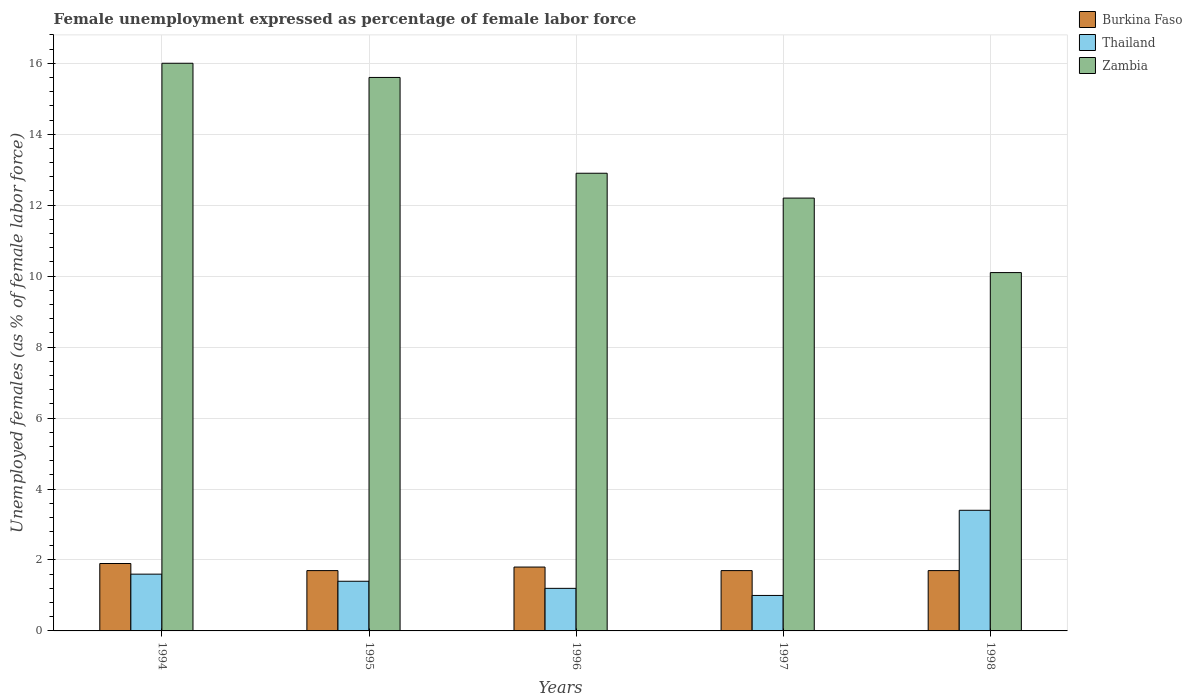How many different coloured bars are there?
Your response must be concise. 3. How many groups of bars are there?
Offer a terse response. 5. Are the number of bars per tick equal to the number of legend labels?
Provide a short and direct response. Yes. Are the number of bars on each tick of the X-axis equal?
Give a very brief answer. Yes. What is the unemployment in females in in Burkina Faso in 1998?
Ensure brevity in your answer.  1.7. What is the total unemployment in females in in Burkina Faso in the graph?
Give a very brief answer. 8.8. What is the difference between the unemployment in females in in Burkina Faso in 1996 and that in 1998?
Your answer should be very brief. 0.1. What is the difference between the unemployment in females in in Thailand in 1997 and the unemployment in females in in Zambia in 1998?
Give a very brief answer. -9.1. What is the average unemployment in females in in Zambia per year?
Make the answer very short. 13.36. In the year 1995, what is the difference between the unemployment in females in in Zambia and unemployment in females in in Thailand?
Offer a very short reply. 14.2. What is the difference between the highest and the second highest unemployment in females in in Burkina Faso?
Your response must be concise. 0.1. What is the difference between the highest and the lowest unemployment in females in in Thailand?
Your answer should be compact. 2.4. In how many years, is the unemployment in females in in Thailand greater than the average unemployment in females in in Thailand taken over all years?
Your response must be concise. 1. What does the 3rd bar from the left in 1994 represents?
Ensure brevity in your answer.  Zambia. What does the 3rd bar from the right in 1995 represents?
Your answer should be compact. Burkina Faso. Is it the case that in every year, the sum of the unemployment in females in in Zambia and unemployment in females in in Burkina Faso is greater than the unemployment in females in in Thailand?
Ensure brevity in your answer.  Yes. How many bars are there?
Give a very brief answer. 15. Are all the bars in the graph horizontal?
Your response must be concise. No. Are the values on the major ticks of Y-axis written in scientific E-notation?
Your answer should be compact. No. Where does the legend appear in the graph?
Offer a terse response. Top right. How many legend labels are there?
Ensure brevity in your answer.  3. How are the legend labels stacked?
Your response must be concise. Vertical. What is the title of the graph?
Your answer should be compact. Female unemployment expressed as percentage of female labor force. Does "Haiti" appear as one of the legend labels in the graph?
Provide a succinct answer. No. What is the label or title of the X-axis?
Your response must be concise. Years. What is the label or title of the Y-axis?
Offer a terse response. Unemployed females (as % of female labor force). What is the Unemployed females (as % of female labor force) of Burkina Faso in 1994?
Provide a short and direct response. 1.9. What is the Unemployed females (as % of female labor force) of Thailand in 1994?
Give a very brief answer. 1.6. What is the Unemployed females (as % of female labor force) of Zambia in 1994?
Your answer should be compact. 16. What is the Unemployed females (as % of female labor force) of Burkina Faso in 1995?
Offer a very short reply. 1.7. What is the Unemployed females (as % of female labor force) of Thailand in 1995?
Offer a very short reply. 1.4. What is the Unemployed females (as % of female labor force) in Zambia in 1995?
Provide a short and direct response. 15.6. What is the Unemployed females (as % of female labor force) in Burkina Faso in 1996?
Your response must be concise. 1.8. What is the Unemployed females (as % of female labor force) in Thailand in 1996?
Offer a very short reply. 1.2. What is the Unemployed females (as % of female labor force) in Zambia in 1996?
Your answer should be very brief. 12.9. What is the Unemployed females (as % of female labor force) in Burkina Faso in 1997?
Your response must be concise. 1.7. What is the Unemployed females (as % of female labor force) of Thailand in 1997?
Offer a very short reply. 1. What is the Unemployed females (as % of female labor force) of Zambia in 1997?
Offer a very short reply. 12.2. What is the Unemployed females (as % of female labor force) in Burkina Faso in 1998?
Make the answer very short. 1.7. What is the Unemployed females (as % of female labor force) of Thailand in 1998?
Ensure brevity in your answer.  3.4. What is the Unemployed females (as % of female labor force) in Zambia in 1998?
Make the answer very short. 10.1. Across all years, what is the maximum Unemployed females (as % of female labor force) in Burkina Faso?
Your answer should be compact. 1.9. Across all years, what is the maximum Unemployed females (as % of female labor force) in Thailand?
Give a very brief answer. 3.4. Across all years, what is the minimum Unemployed females (as % of female labor force) of Burkina Faso?
Offer a very short reply. 1.7. Across all years, what is the minimum Unemployed females (as % of female labor force) of Thailand?
Keep it short and to the point. 1. Across all years, what is the minimum Unemployed females (as % of female labor force) in Zambia?
Provide a succinct answer. 10.1. What is the total Unemployed females (as % of female labor force) in Burkina Faso in the graph?
Keep it short and to the point. 8.8. What is the total Unemployed females (as % of female labor force) in Thailand in the graph?
Keep it short and to the point. 8.6. What is the total Unemployed females (as % of female labor force) of Zambia in the graph?
Your response must be concise. 66.8. What is the difference between the Unemployed females (as % of female labor force) in Thailand in 1994 and that in 1996?
Provide a short and direct response. 0.4. What is the difference between the Unemployed females (as % of female labor force) in Zambia in 1994 and that in 1998?
Provide a short and direct response. 5.9. What is the difference between the Unemployed females (as % of female labor force) of Burkina Faso in 1995 and that in 1996?
Keep it short and to the point. -0.1. What is the difference between the Unemployed females (as % of female labor force) in Thailand in 1995 and that in 1996?
Give a very brief answer. 0.2. What is the difference between the Unemployed females (as % of female labor force) in Zambia in 1995 and that in 1996?
Provide a short and direct response. 2.7. What is the difference between the Unemployed females (as % of female labor force) in Burkina Faso in 1995 and that in 1997?
Provide a succinct answer. 0. What is the difference between the Unemployed females (as % of female labor force) in Thailand in 1996 and that in 1997?
Keep it short and to the point. 0.2. What is the difference between the Unemployed females (as % of female labor force) of Zambia in 1996 and that in 1997?
Your answer should be very brief. 0.7. What is the difference between the Unemployed females (as % of female labor force) in Burkina Faso in 1996 and that in 1998?
Offer a terse response. 0.1. What is the difference between the Unemployed females (as % of female labor force) of Thailand in 1996 and that in 1998?
Give a very brief answer. -2.2. What is the difference between the Unemployed females (as % of female labor force) in Zambia in 1996 and that in 1998?
Your response must be concise. 2.8. What is the difference between the Unemployed females (as % of female labor force) of Thailand in 1997 and that in 1998?
Ensure brevity in your answer.  -2.4. What is the difference between the Unemployed females (as % of female labor force) of Zambia in 1997 and that in 1998?
Provide a succinct answer. 2.1. What is the difference between the Unemployed females (as % of female labor force) in Burkina Faso in 1994 and the Unemployed females (as % of female labor force) in Zambia in 1995?
Offer a terse response. -13.7. What is the difference between the Unemployed females (as % of female labor force) of Burkina Faso in 1994 and the Unemployed females (as % of female labor force) of Thailand in 1996?
Ensure brevity in your answer.  0.7. What is the difference between the Unemployed females (as % of female labor force) in Thailand in 1994 and the Unemployed females (as % of female labor force) in Zambia in 1996?
Make the answer very short. -11.3. What is the difference between the Unemployed females (as % of female labor force) in Burkina Faso in 1994 and the Unemployed females (as % of female labor force) in Zambia in 1997?
Your answer should be very brief. -10.3. What is the difference between the Unemployed females (as % of female labor force) of Burkina Faso in 1994 and the Unemployed females (as % of female labor force) of Zambia in 1998?
Provide a short and direct response. -8.2. What is the difference between the Unemployed females (as % of female labor force) in Thailand in 1995 and the Unemployed females (as % of female labor force) in Zambia in 1997?
Provide a succinct answer. -10.8. What is the difference between the Unemployed females (as % of female labor force) of Burkina Faso in 1995 and the Unemployed females (as % of female labor force) of Zambia in 1998?
Make the answer very short. -8.4. What is the difference between the Unemployed females (as % of female labor force) in Burkina Faso in 1996 and the Unemployed females (as % of female labor force) in Thailand in 1997?
Your answer should be compact. 0.8. What is the difference between the Unemployed females (as % of female labor force) in Burkina Faso in 1996 and the Unemployed females (as % of female labor force) in Zambia in 1997?
Give a very brief answer. -10.4. What is the difference between the Unemployed females (as % of female labor force) of Thailand in 1996 and the Unemployed females (as % of female labor force) of Zambia in 1997?
Your answer should be very brief. -11. What is the difference between the Unemployed females (as % of female labor force) in Burkina Faso in 1996 and the Unemployed females (as % of female labor force) in Zambia in 1998?
Your response must be concise. -8.3. What is the difference between the Unemployed females (as % of female labor force) in Thailand in 1996 and the Unemployed females (as % of female labor force) in Zambia in 1998?
Provide a short and direct response. -8.9. What is the difference between the Unemployed females (as % of female labor force) of Thailand in 1997 and the Unemployed females (as % of female labor force) of Zambia in 1998?
Offer a very short reply. -9.1. What is the average Unemployed females (as % of female labor force) of Burkina Faso per year?
Your response must be concise. 1.76. What is the average Unemployed females (as % of female labor force) of Thailand per year?
Your response must be concise. 1.72. What is the average Unemployed females (as % of female labor force) in Zambia per year?
Your response must be concise. 13.36. In the year 1994, what is the difference between the Unemployed females (as % of female labor force) of Burkina Faso and Unemployed females (as % of female labor force) of Zambia?
Ensure brevity in your answer.  -14.1. In the year 1994, what is the difference between the Unemployed females (as % of female labor force) in Thailand and Unemployed females (as % of female labor force) in Zambia?
Your response must be concise. -14.4. In the year 1995, what is the difference between the Unemployed females (as % of female labor force) in Burkina Faso and Unemployed females (as % of female labor force) in Thailand?
Give a very brief answer. 0.3. In the year 1995, what is the difference between the Unemployed females (as % of female labor force) in Burkina Faso and Unemployed females (as % of female labor force) in Zambia?
Provide a succinct answer. -13.9. In the year 1996, what is the difference between the Unemployed females (as % of female labor force) in Burkina Faso and Unemployed females (as % of female labor force) in Thailand?
Your answer should be very brief. 0.6. In the year 1998, what is the difference between the Unemployed females (as % of female labor force) of Burkina Faso and Unemployed females (as % of female labor force) of Zambia?
Make the answer very short. -8.4. In the year 1998, what is the difference between the Unemployed females (as % of female labor force) in Thailand and Unemployed females (as % of female labor force) in Zambia?
Ensure brevity in your answer.  -6.7. What is the ratio of the Unemployed females (as % of female labor force) of Burkina Faso in 1994 to that in 1995?
Offer a terse response. 1.12. What is the ratio of the Unemployed females (as % of female labor force) of Zambia in 1994 to that in 1995?
Provide a succinct answer. 1.03. What is the ratio of the Unemployed females (as % of female labor force) in Burkina Faso in 1994 to that in 1996?
Ensure brevity in your answer.  1.06. What is the ratio of the Unemployed females (as % of female labor force) of Zambia in 1994 to that in 1996?
Offer a terse response. 1.24. What is the ratio of the Unemployed females (as % of female labor force) of Burkina Faso in 1994 to that in 1997?
Provide a short and direct response. 1.12. What is the ratio of the Unemployed females (as % of female labor force) in Zambia in 1994 to that in 1997?
Your response must be concise. 1.31. What is the ratio of the Unemployed females (as % of female labor force) in Burkina Faso in 1994 to that in 1998?
Provide a short and direct response. 1.12. What is the ratio of the Unemployed females (as % of female labor force) of Thailand in 1994 to that in 1998?
Offer a terse response. 0.47. What is the ratio of the Unemployed females (as % of female labor force) of Zambia in 1994 to that in 1998?
Give a very brief answer. 1.58. What is the ratio of the Unemployed females (as % of female labor force) of Burkina Faso in 1995 to that in 1996?
Make the answer very short. 0.94. What is the ratio of the Unemployed females (as % of female labor force) of Zambia in 1995 to that in 1996?
Make the answer very short. 1.21. What is the ratio of the Unemployed females (as % of female labor force) in Burkina Faso in 1995 to that in 1997?
Keep it short and to the point. 1. What is the ratio of the Unemployed females (as % of female labor force) of Zambia in 1995 to that in 1997?
Make the answer very short. 1.28. What is the ratio of the Unemployed females (as % of female labor force) of Thailand in 1995 to that in 1998?
Provide a short and direct response. 0.41. What is the ratio of the Unemployed females (as % of female labor force) in Zambia in 1995 to that in 1998?
Your response must be concise. 1.54. What is the ratio of the Unemployed females (as % of female labor force) in Burkina Faso in 1996 to that in 1997?
Your answer should be compact. 1.06. What is the ratio of the Unemployed females (as % of female labor force) in Thailand in 1996 to that in 1997?
Keep it short and to the point. 1.2. What is the ratio of the Unemployed females (as % of female labor force) of Zambia in 1996 to that in 1997?
Offer a very short reply. 1.06. What is the ratio of the Unemployed females (as % of female labor force) in Burkina Faso in 1996 to that in 1998?
Provide a succinct answer. 1.06. What is the ratio of the Unemployed females (as % of female labor force) of Thailand in 1996 to that in 1998?
Offer a very short reply. 0.35. What is the ratio of the Unemployed females (as % of female labor force) in Zambia in 1996 to that in 1998?
Your response must be concise. 1.28. What is the ratio of the Unemployed females (as % of female labor force) of Thailand in 1997 to that in 1998?
Offer a very short reply. 0.29. What is the ratio of the Unemployed females (as % of female labor force) in Zambia in 1997 to that in 1998?
Provide a succinct answer. 1.21. What is the difference between the highest and the second highest Unemployed females (as % of female labor force) of Thailand?
Make the answer very short. 1.8. What is the difference between the highest and the lowest Unemployed females (as % of female labor force) in Burkina Faso?
Provide a succinct answer. 0.2. 